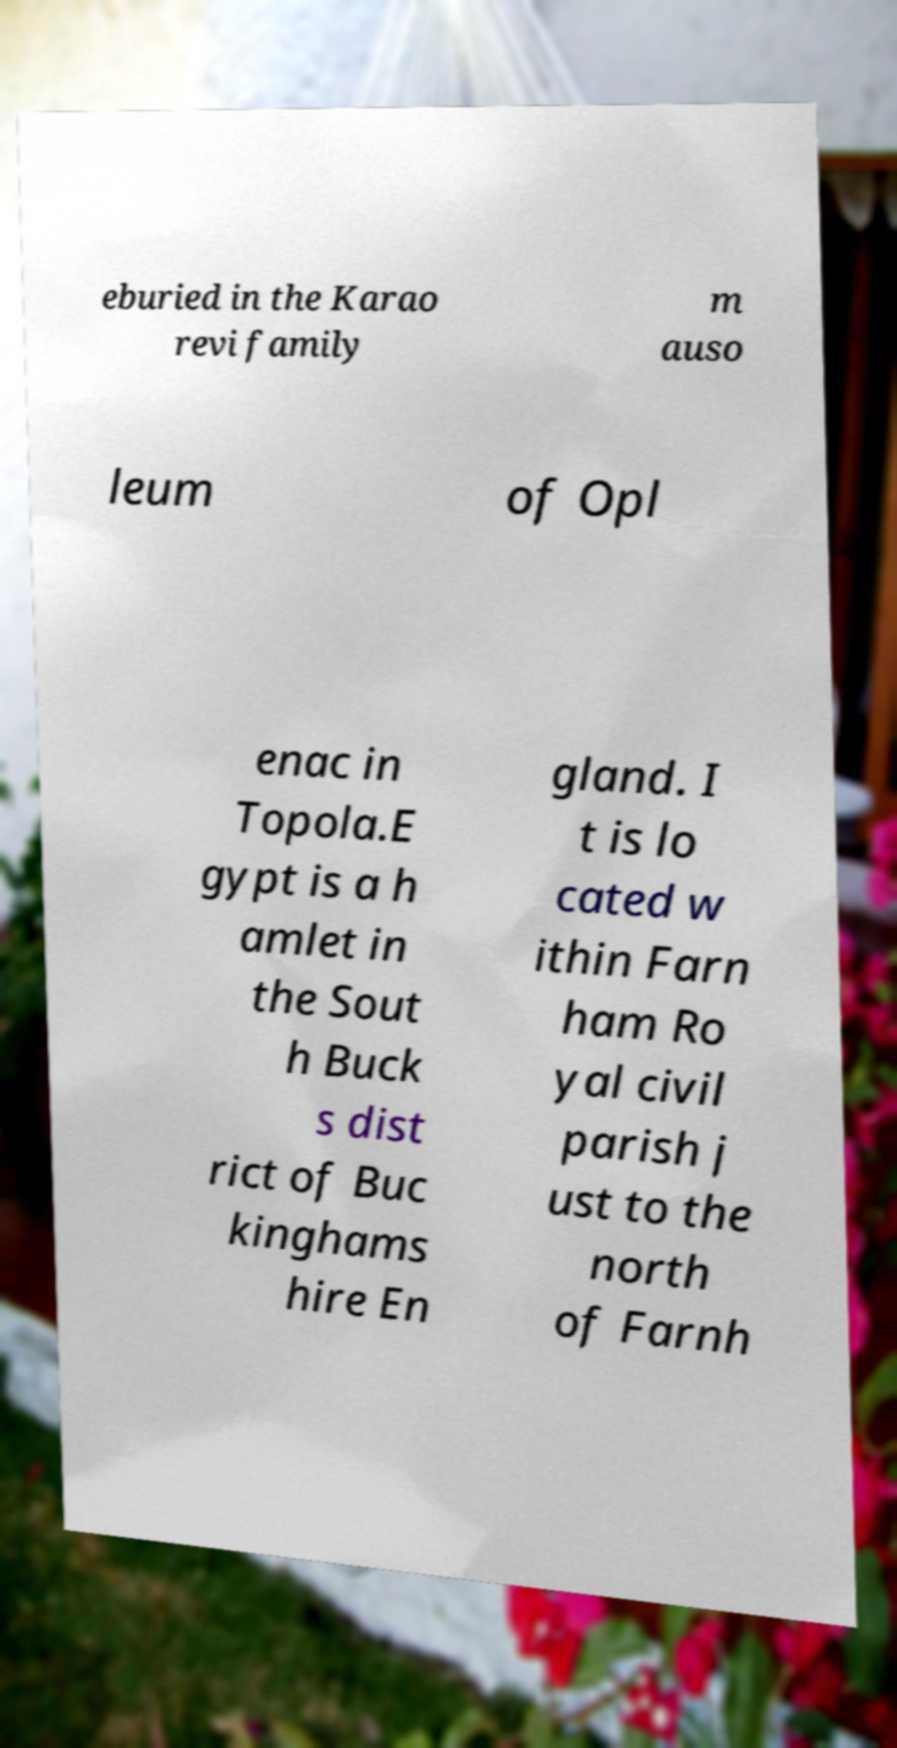I need the written content from this picture converted into text. Can you do that? eburied in the Karao revi family m auso leum of Opl enac in Topola.E gypt is a h amlet in the Sout h Buck s dist rict of Buc kinghams hire En gland. I t is lo cated w ithin Farn ham Ro yal civil parish j ust to the north of Farnh 